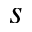<formula> <loc_0><loc_0><loc_500><loc_500>s</formula> 